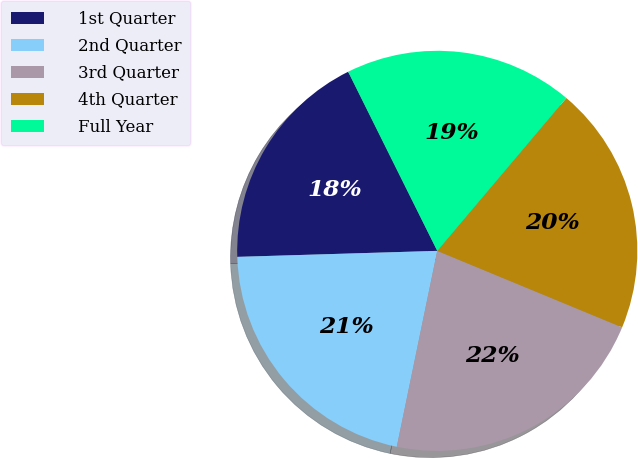<chart> <loc_0><loc_0><loc_500><loc_500><pie_chart><fcel>1st Quarter<fcel>2nd Quarter<fcel>3rd Quarter<fcel>4th Quarter<fcel>Full Year<nl><fcel>18.13%<fcel>21.28%<fcel>22.0%<fcel>20.08%<fcel>18.51%<nl></chart> 